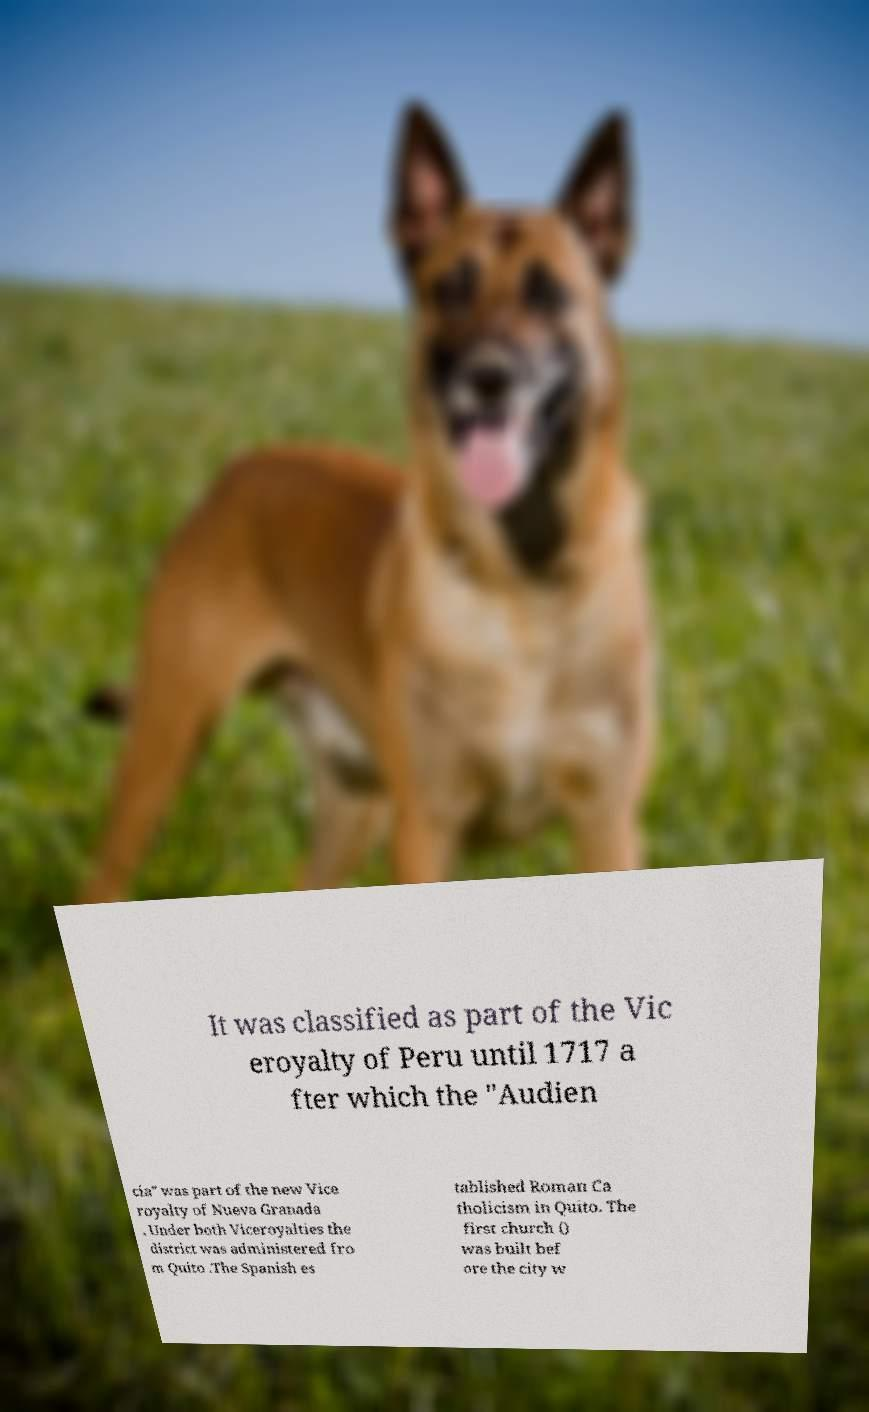What messages or text are displayed in this image? I need them in a readable, typed format. It was classified as part of the Vic eroyalty of Peru until 1717 a fter which the "Audien cia" was part of the new Vice royalty of Nueva Granada . Under both Viceroyalties the district was administered fro m Quito .The Spanish es tablished Roman Ca tholicism in Quito. The first church () was built bef ore the city w 